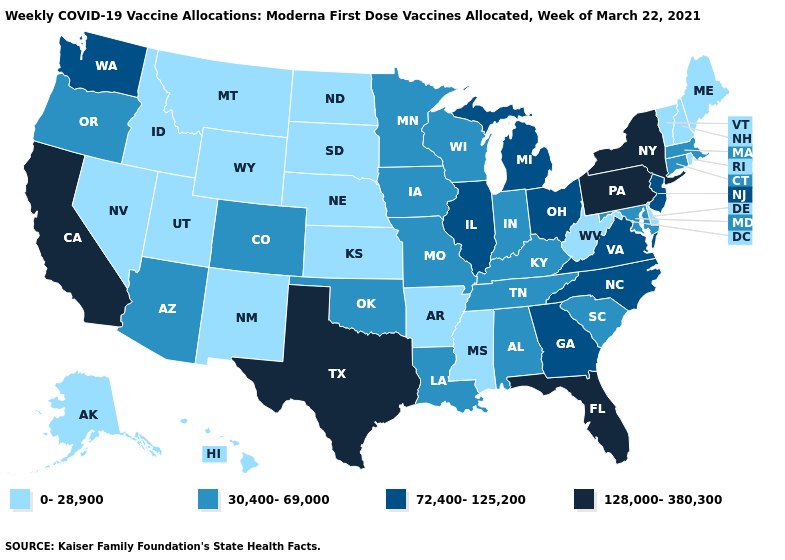Does the map have missing data?
Concise answer only. No. Does the map have missing data?
Keep it brief. No. Name the states that have a value in the range 0-28,900?
Short answer required. Alaska, Arkansas, Delaware, Hawaii, Idaho, Kansas, Maine, Mississippi, Montana, Nebraska, Nevada, New Hampshire, New Mexico, North Dakota, Rhode Island, South Dakota, Utah, Vermont, West Virginia, Wyoming. What is the value of Colorado?
Quick response, please. 30,400-69,000. What is the lowest value in states that border Indiana?
Keep it brief. 30,400-69,000. What is the value of Alaska?
Give a very brief answer. 0-28,900. What is the lowest value in the West?
Short answer required. 0-28,900. What is the value of Utah?
Keep it brief. 0-28,900. Which states have the highest value in the USA?
Quick response, please. California, Florida, New York, Pennsylvania, Texas. Among the states that border Texas , does Arkansas have the highest value?
Concise answer only. No. What is the highest value in states that border Missouri?
Be succinct. 72,400-125,200. Does California have the highest value in the West?
Concise answer only. Yes. Does the first symbol in the legend represent the smallest category?
Concise answer only. Yes. Does Oklahoma have the lowest value in the USA?
Concise answer only. No. What is the value of Florida?
Concise answer only. 128,000-380,300. 